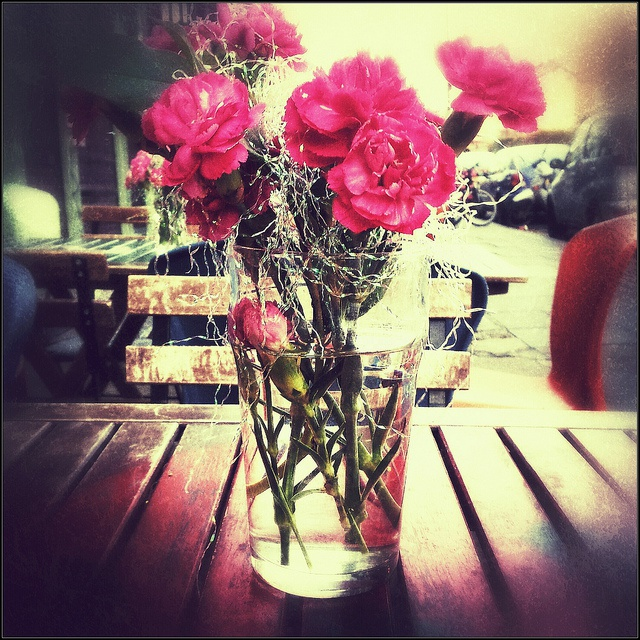Describe the objects in this image and their specific colors. I can see dining table in black, khaki, purple, and lightyellow tones, vase in black, khaki, lightyellow, and gray tones, dining table in black, khaki, gray, and darkgray tones, chair in black, maroon, khaki, brown, and lightyellow tones, and bench in black, khaki, lightyellow, and tan tones in this image. 